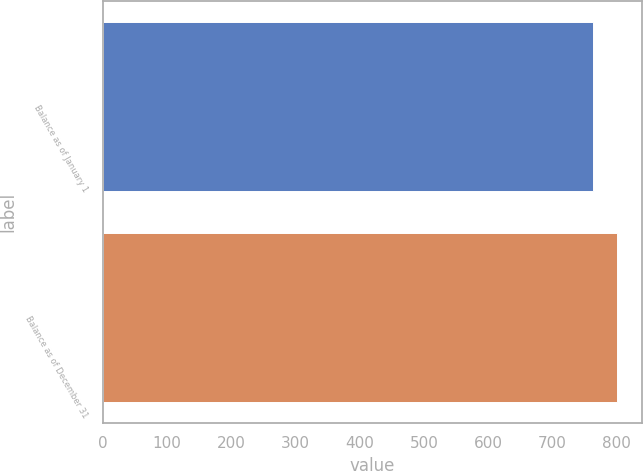Convert chart to OTSL. <chart><loc_0><loc_0><loc_500><loc_500><bar_chart><fcel>Balance as of January 1<fcel>Balance as of December 31<nl><fcel>763<fcel>800<nl></chart> 